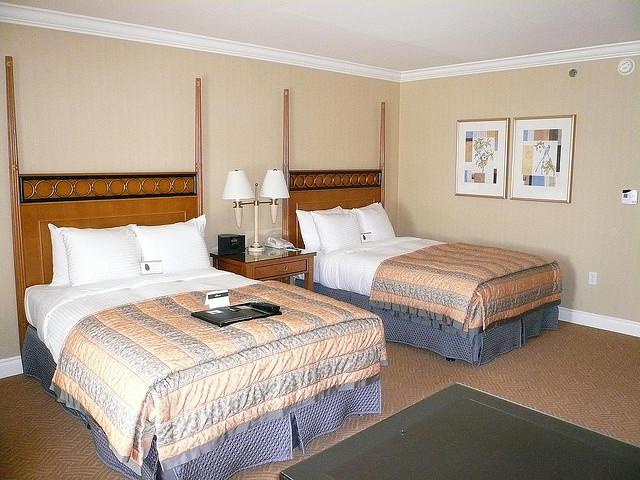How many lights are turned on?
Short answer required. 0. How many beds are there?
Write a very short answer. 2. Where is the telephone in this photo?
Keep it brief. Nightstand. Are these beds made up?
Write a very short answer. Yes. What color is the rug?
Be succinct. Tan. Is this a hotel room?
Answer briefly. Yes. 